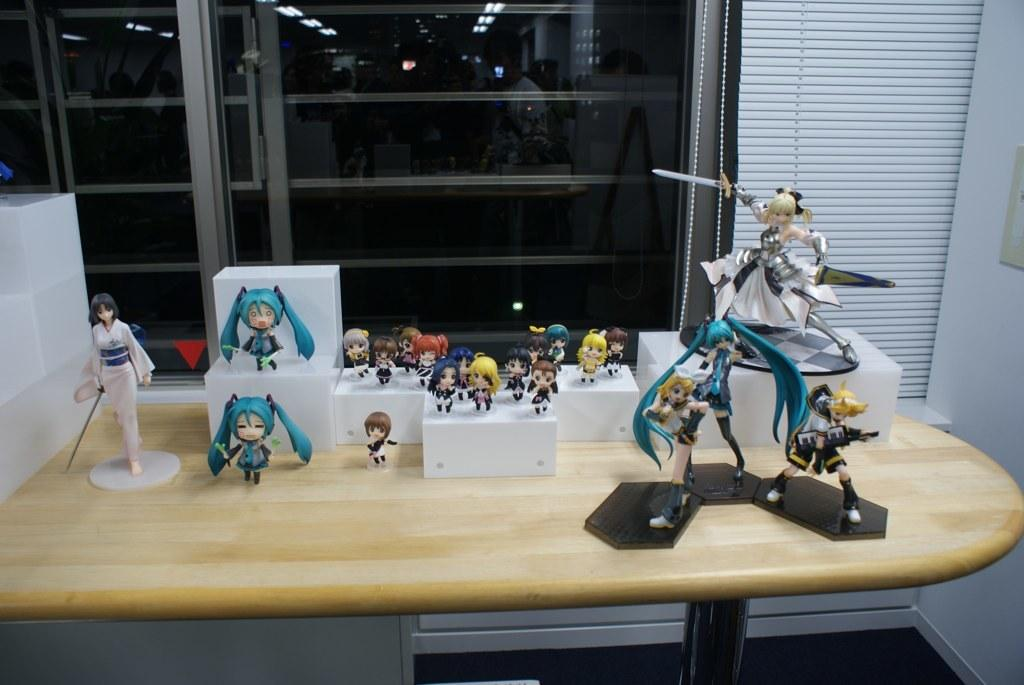What type of toys can be seen in the image? There are girl toys in the image. What else is present in the image besides the toys? There are boxes and a knife visible in the image. How are the toys arranged in the image? The toys are arranged in an order on a table. What can be seen in the background of the image? There is a window in the background of the image. What type of toothpaste is being used to decorate the toys in the image? There is no toothpaste present in the image, and the toys are not being decorated. 